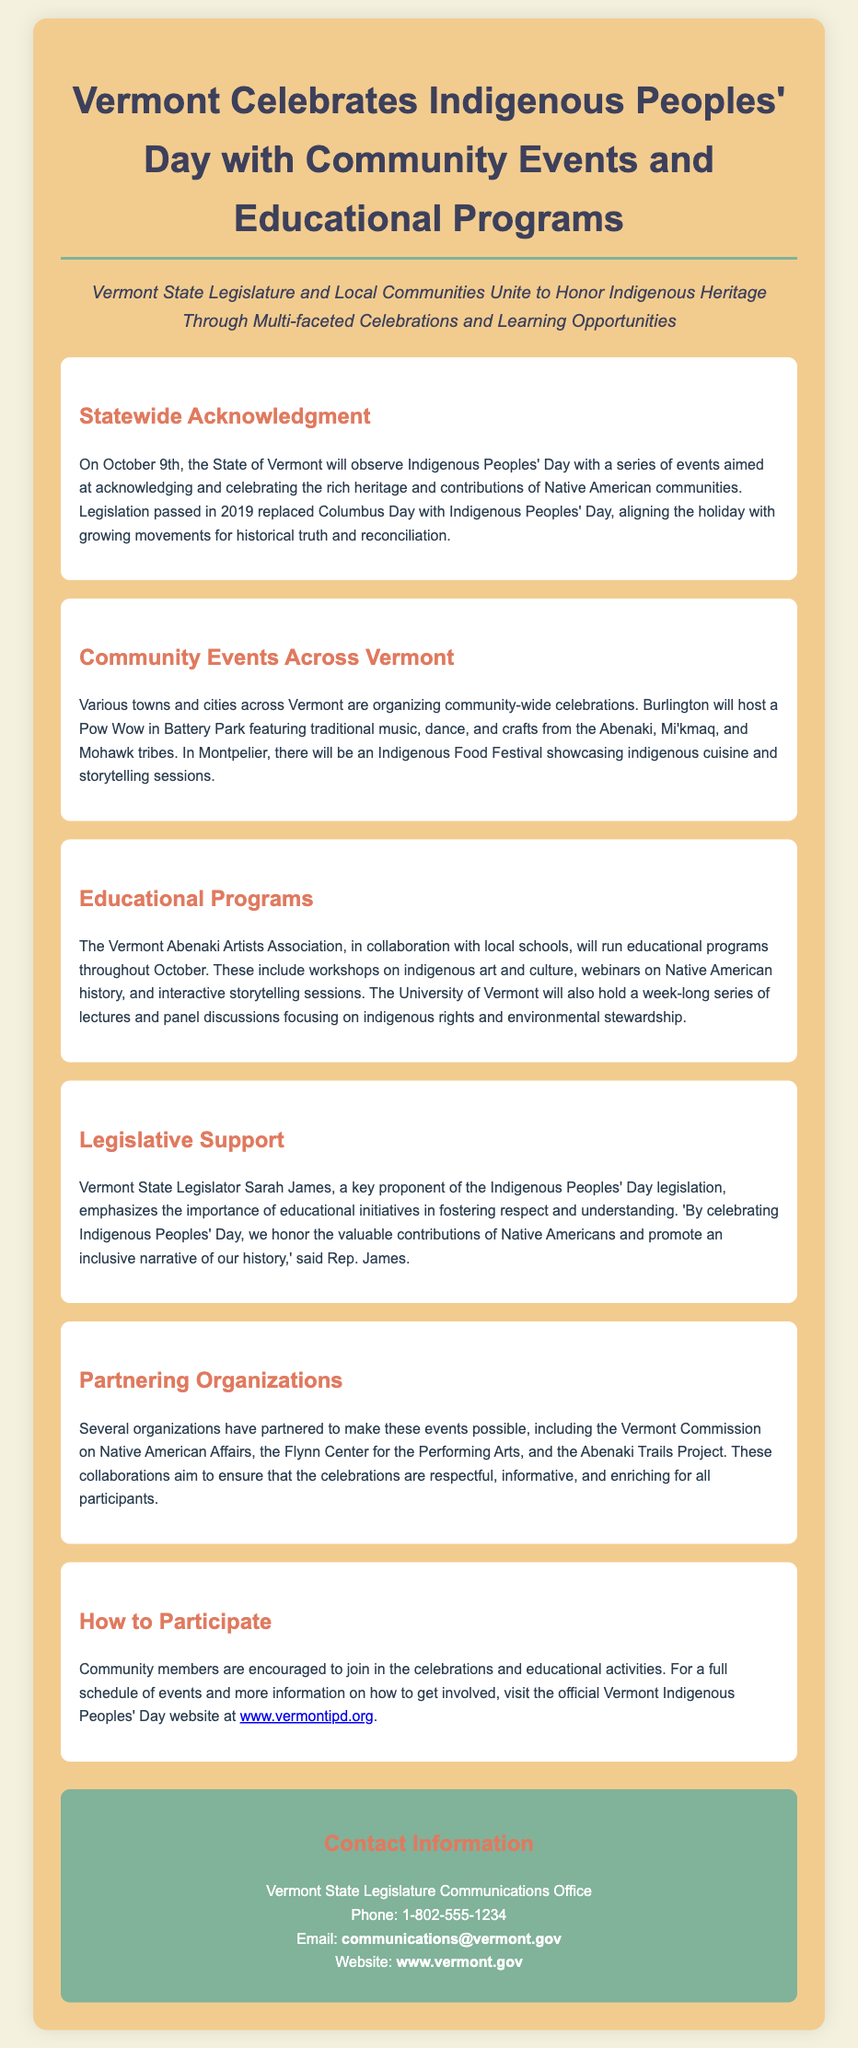What day will Vermont observe Indigenous Peoples' Day? The document states that Vermont will observe Indigenous Peoples' Day on October 9th.
Answer: October 9th Who is a key proponent of the Indigenous Peoples' Day legislation? The document mentions Vermont State Legislator Sarah James as a key proponent.
Answer: Sarah James What type of festival will be held in Montpelier? The document details an Indigenous Food Festival taking place in Montpelier.
Answer: Indigenous Food Festival Which organization will run educational programs throughout October? The Vermont Abenaki Artists Association is mentioned as the organization running educational programs.
Answer: Vermont Abenaki Artists Association What will Burlington host in Battery Park? The document states that Burlington will host a Pow Wow in Battery Park.
Answer: Pow Wow How many organizations are mentioned as partners for the event? The document lists several organizations, specifically mentioning three by name as partners.
Answer: Three What does Rep. Sarah James emphasize in her statement? The document states she emphasizes the importance of educational initiatives in fostering respect and understanding.
Answer: Educational initiatives What can community members do to get involved? Community members are encouraged to join in the celebrations and educational activities.
Answer: Join celebrations and activities 